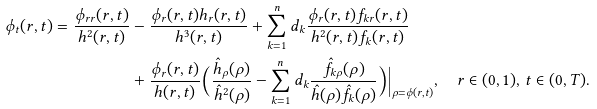<formula> <loc_0><loc_0><loc_500><loc_500>\phi _ { t } ( r , t ) = \frac { \phi _ { r r } ( r , t ) } { h ^ { 2 } ( r , t ) } & - \frac { \phi _ { r } ( r , t ) h _ { r } ( r , t ) } { h ^ { 3 } ( r , t ) } + \sum _ { k = 1 } ^ { n } d _ { k } \frac { \phi _ { r } ( r , t ) f _ { k r } ( r , t ) } { h ^ { 2 } ( r , t ) f _ { k } ( r , t ) } \\ & + \frac { \phi _ { r } ( r , t ) } { h ( r , t ) } \Big ( \frac { \hat { h } _ { \rho } ( \rho ) } { \hat { h } ^ { 2 } ( \rho ) } - \sum _ { k = 1 } ^ { n } d _ { k } \frac { \hat { f } _ { k \rho } ( \rho ) } { \hat { h } ( \rho ) \hat { f } _ { k } ( \rho ) } \Big ) \Big | _ { \rho = \phi ( r , t ) } , \quad r \in ( 0 , 1 ) , \, t \in ( 0 , T ) .</formula> 